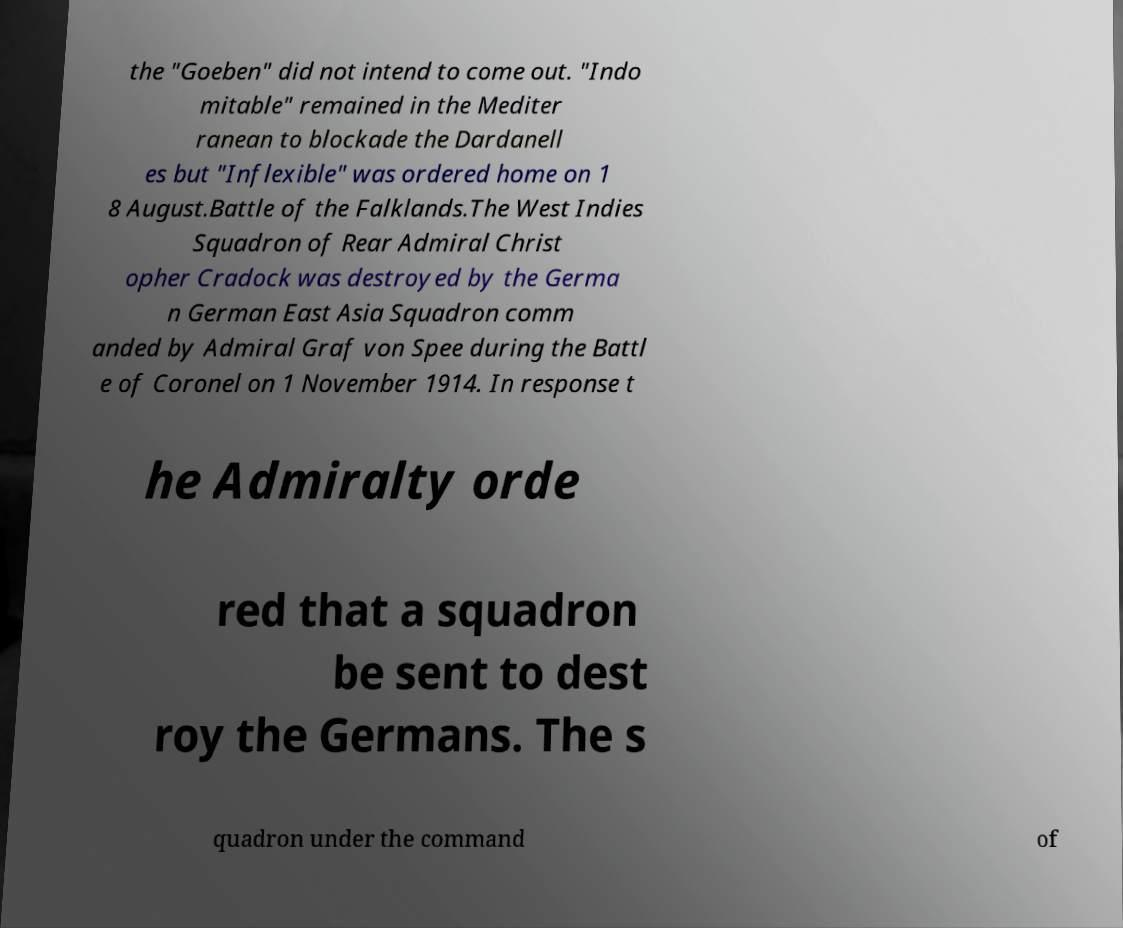Could you assist in decoding the text presented in this image and type it out clearly? the "Goeben" did not intend to come out. "Indo mitable" remained in the Mediter ranean to blockade the Dardanell es but "Inflexible" was ordered home on 1 8 August.Battle of the Falklands.The West Indies Squadron of Rear Admiral Christ opher Cradock was destroyed by the Germa n German East Asia Squadron comm anded by Admiral Graf von Spee during the Battl e of Coronel on 1 November 1914. In response t he Admiralty orde red that a squadron be sent to dest roy the Germans. The s quadron under the command of 